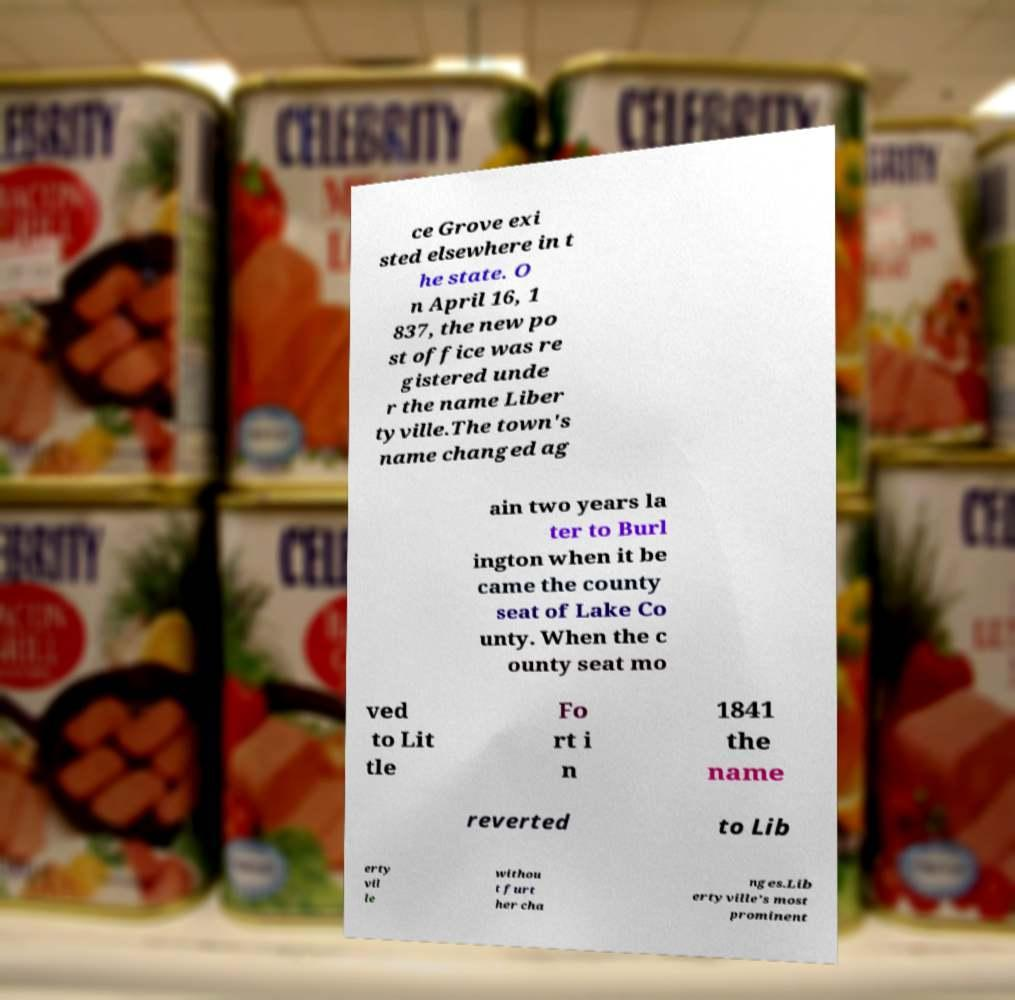I need the written content from this picture converted into text. Can you do that? ce Grove exi sted elsewhere in t he state. O n April 16, 1 837, the new po st office was re gistered unde r the name Liber tyville.The town's name changed ag ain two years la ter to Burl ington when it be came the county seat of Lake Co unty. When the c ounty seat mo ved to Lit tle Fo rt i n 1841 the name reverted to Lib erty vil le withou t furt her cha nges.Lib ertyville's most prominent 